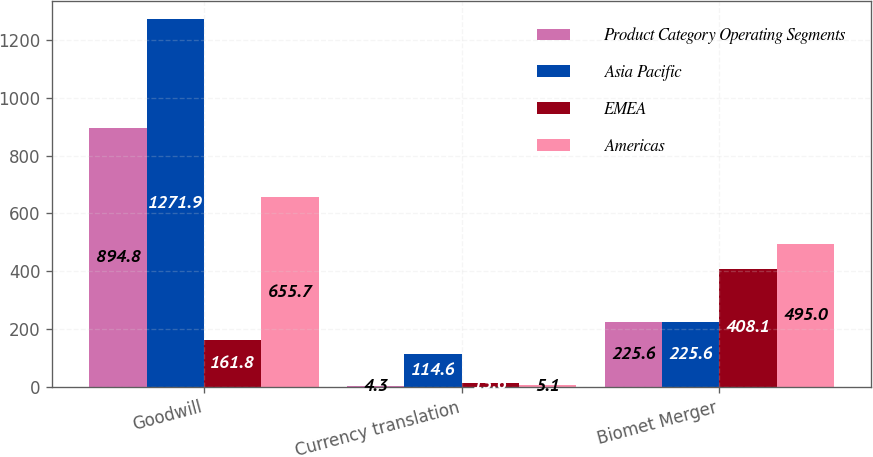<chart> <loc_0><loc_0><loc_500><loc_500><stacked_bar_chart><ecel><fcel>Goodwill<fcel>Currency translation<fcel>Biomet Merger<nl><fcel>Product Category Operating Segments<fcel>894.8<fcel>4.3<fcel>225.6<nl><fcel>Asia Pacific<fcel>1271.9<fcel>114.6<fcel>225.6<nl><fcel>EMEA<fcel>161.8<fcel>13.6<fcel>408.1<nl><fcel>Americas<fcel>655.7<fcel>5.1<fcel>495<nl></chart> 